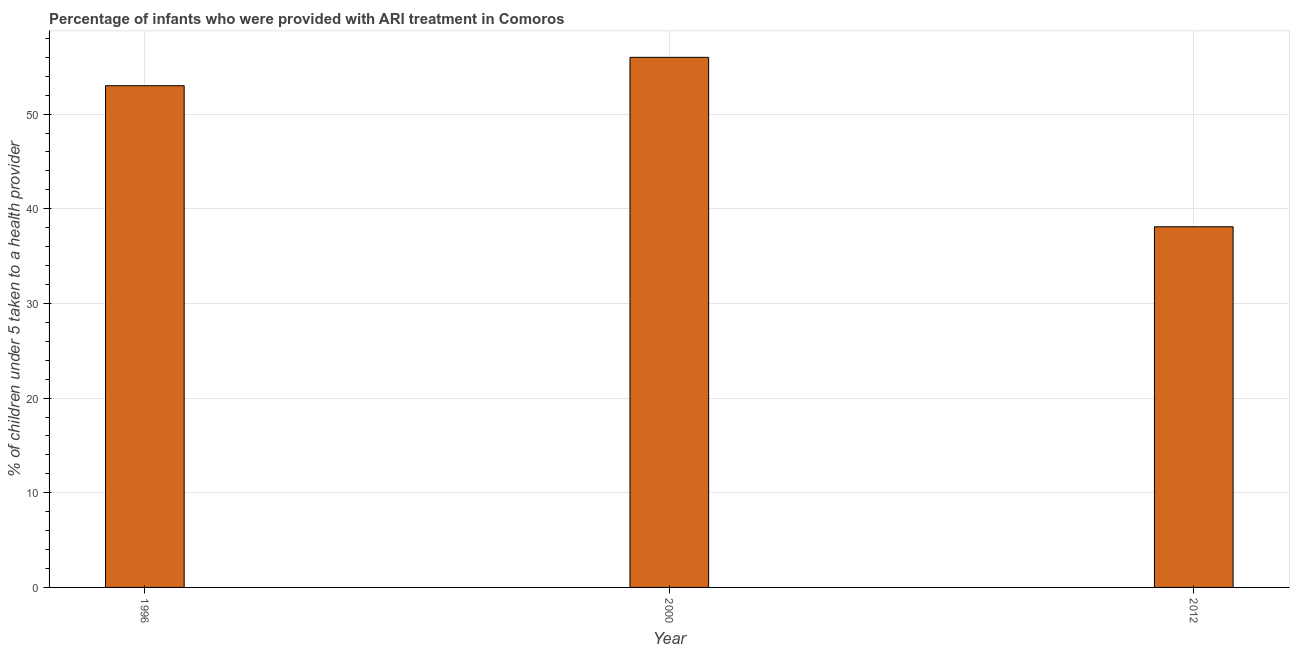Does the graph contain grids?
Your response must be concise. Yes. What is the title of the graph?
Give a very brief answer. Percentage of infants who were provided with ARI treatment in Comoros. What is the label or title of the Y-axis?
Offer a very short reply. % of children under 5 taken to a health provider. Across all years, what is the minimum percentage of children who were provided with ari treatment?
Offer a very short reply. 38.1. In which year was the percentage of children who were provided with ari treatment maximum?
Give a very brief answer. 2000. What is the sum of the percentage of children who were provided with ari treatment?
Keep it short and to the point. 147.1. What is the difference between the percentage of children who were provided with ari treatment in 2000 and 2012?
Provide a succinct answer. 17.9. What is the average percentage of children who were provided with ari treatment per year?
Make the answer very short. 49.03. Do a majority of the years between 1996 and 2012 (inclusive) have percentage of children who were provided with ari treatment greater than 16 %?
Keep it short and to the point. Yes. What is the ratio of the percentage of children who were provided with ari treatment in 1996 to that in 2012?
Ensure brevity in your answer.  1.39. Is the difference between the percentage of children who were provided with ari treatment in 1996 and 2000 greater than the difference between any two years?
Provide a succinct answer. No. Is the sum of the percentage of children who were provided with ari treatment in 1996 and 2012 greater than the maximum percentage of children who were provided with ari treatment across all years?
Offer a very short reply. Yes. What is the difference between the highest and the lowest percentage of children who were provided with ari treatment?
Provide a short and direct response. 17.9. How many bars are there?
Your answer should be compact. 3. Are all the bars in the graph horizontal?
Keep it short and to the point. No. What is the difference between two consecutive major ticks on the Y-axis?
Provide a short and direct response. 10. What is the % of children under 5 taken to a health provider of 1996?
Provide a short and direct response. 53. What is the % of children under 5 taken to a health provider in 2012?
Your answer should be compact. 38.1. What is the difference between the % of children under 5 taken to a health provider in 1996 and 2012?
Give a very brief answer. 14.9. What is the ratio of the % of children under 5 taken to a health provider in 1996 to that in 2000?
Give a very brief answer. 0.95. What is the ratio of the % of children under 5 taken to a health provider in 1996 to that in 2012?
Offer a terse response. 1.39. What is the ratio of the % of children under 5 taken to a health provider in 2000 to that in 2012?
Offer a terse response. 1.47. 